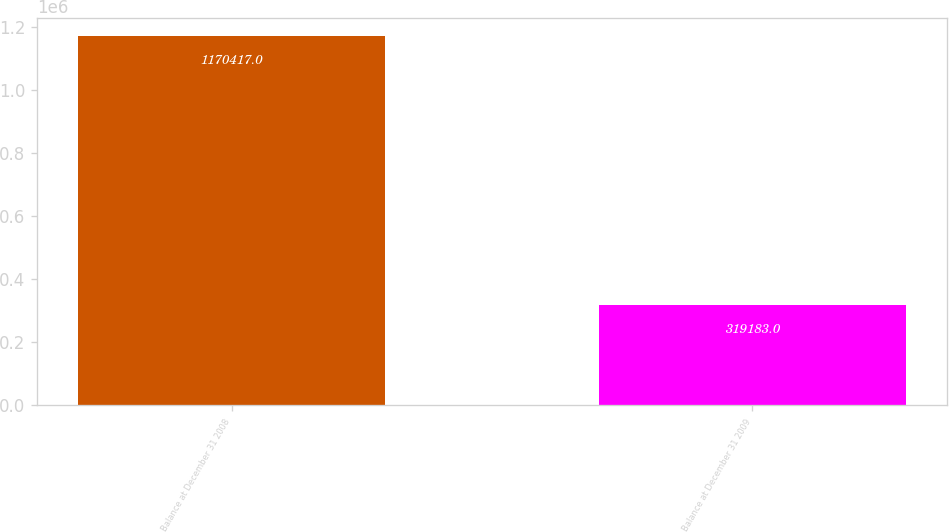Convert chart. <chart><loc_0><loc_0><loc_500><loc_500><bar_chart><fcel>Balance at December 31 2008<fcel>Balance at December 31 2009<nl><fcel>1.17042e+06<fcel>319183<nl></chart> 